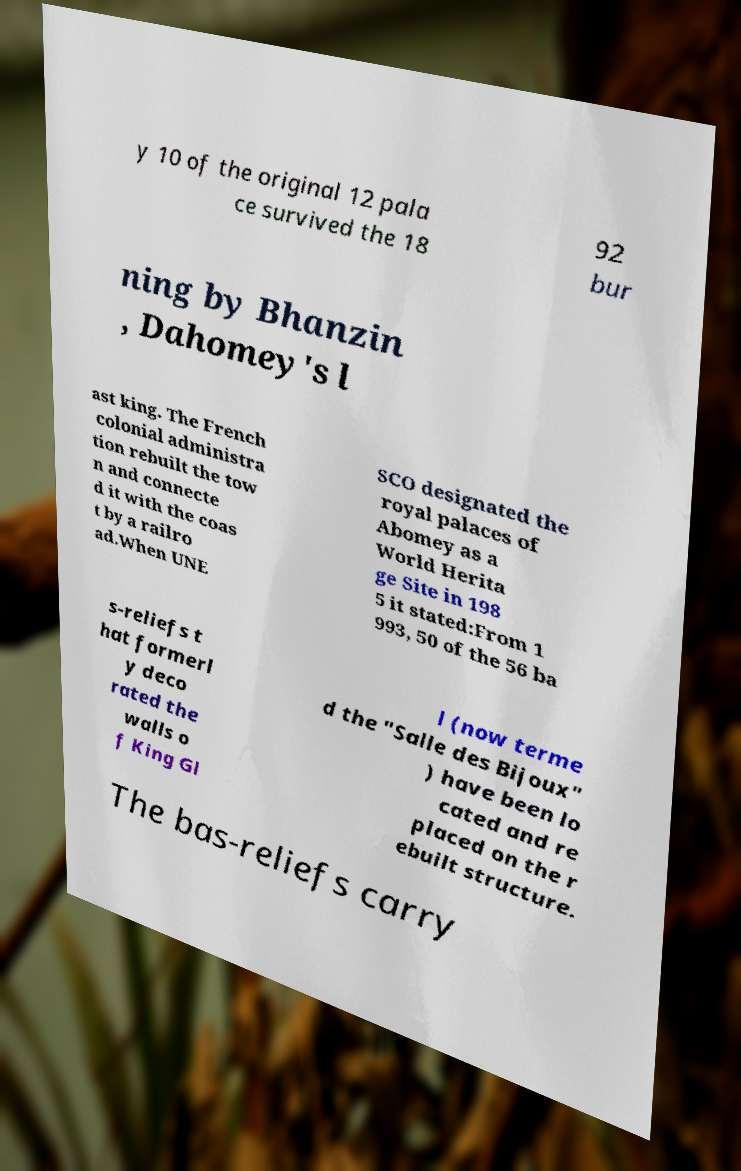Please identify and transcribe the text found in this image. y 10 of the original 12 pala ce survived the 18 92 bur ning by Bhanzin , Dahomey's l ast king. The French colonial administra tion rebuilt the tow n and connecte d it with the coas t by a railro ad.When UNE SCO designated the royal palaces of Abomey as a World Herita ge Site in 198 5 it stated:From 1 993, 50 of the 56 ba s-reliefs t hat formerl y deco rated the walls o f King Gl l (now terme d the "Salle des Bijoux" ) have been lo cated and re placed on the r ebuilt structure. The bas-reliefs carry 